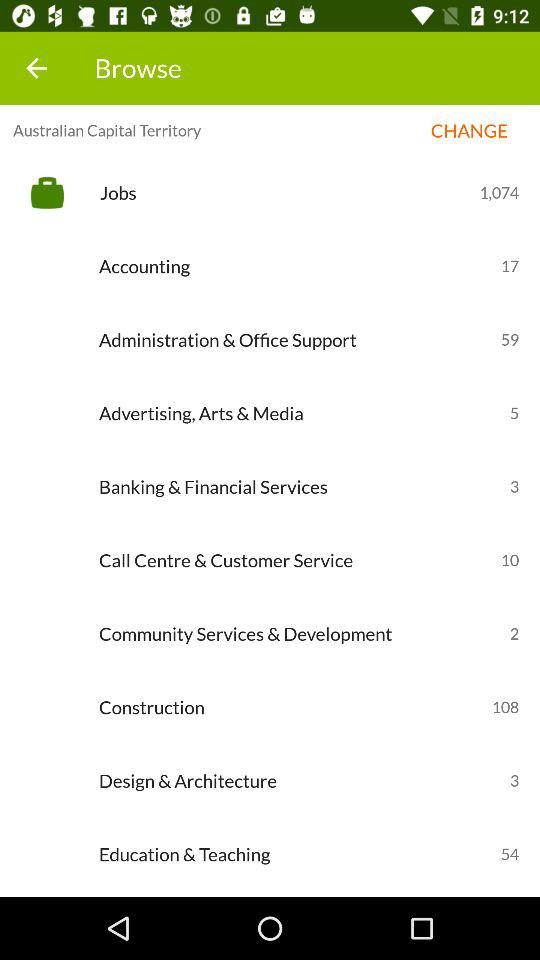How many jobs are in "Design & Architecture"? There are 3 jobs present in design and architecture. 